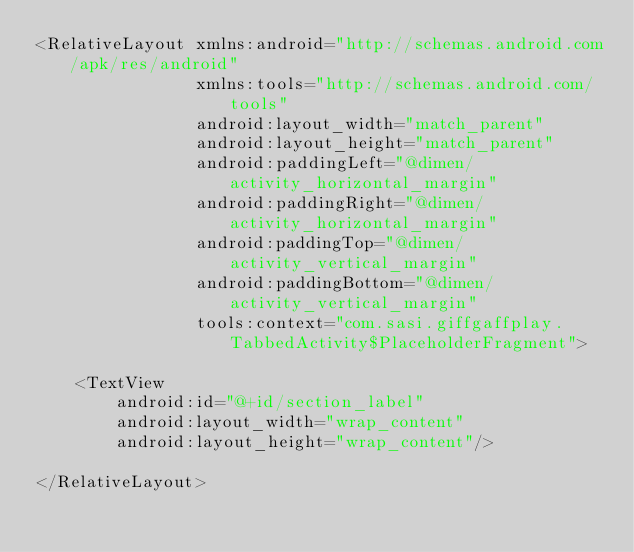<code> <loc_0><loc_0><loc_500><loc_500><_XML_><RelativeLayout xmlns:android="http://schemas.android.com/apk/res/android"
                xmlns:tools="http://schemas.android.com/tools"
                android:layout_width="match_parent"
                android:layout_height="match_parent"
                android:paddingLeft="@dimen/activity_horizontal_margin"
                android:paddingRight="@dimen/activity_horizontal_margin"
                android:paddingTop="@dimen/activity_vertical_margin"
                android:paddingBottom="@dimen/activity_vertical_margin"
                tools:context="com.sasi.giffgaffplay.TabbedActivity$PlaceholderFragment">

    <TextView
        android:id="@+id/section_label"
        android:layout_width="wrap_content"
        android:layout_height="wrap_content"/>

</RelativeLayout>
</code> 